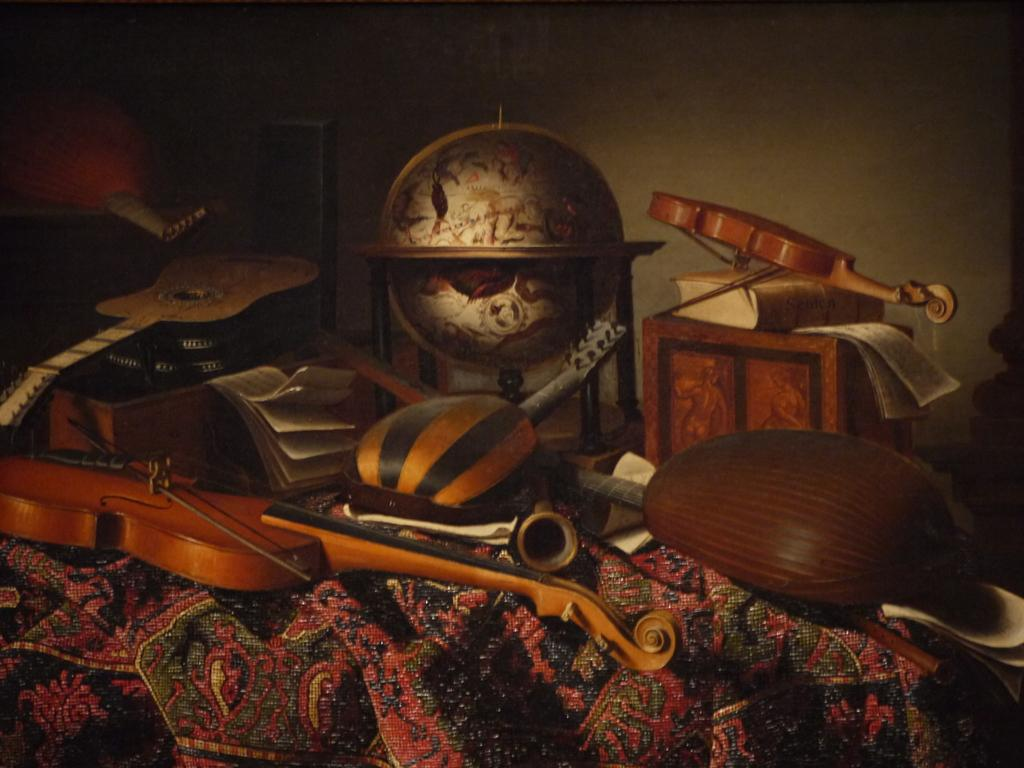What is the main object in the image? There is a table in the image. What items can be seen on the table? There are books and musical instruments on the table. What can be seen in the background of the image? There are walls visible in the background of the image. Can you tell me how many kitties are playing with the musical instruments in the image? There are no kitties present in the image; it only features books and musical instruments on the table. What act is being performed by the people in the image? There are no people visible in the image, so it is impossible to determine what act they might be performing. 